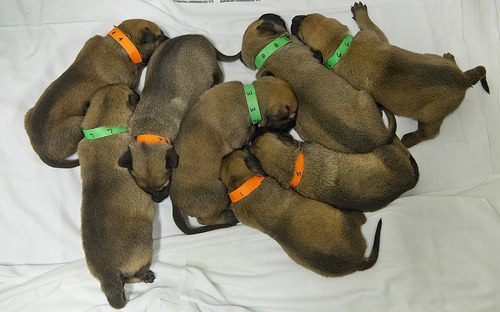<image>
Can you confirm if the dog is on the bed? Yes. Looking at the image, I can see the dog is positioned on top of the bed, with the bed providing support. 